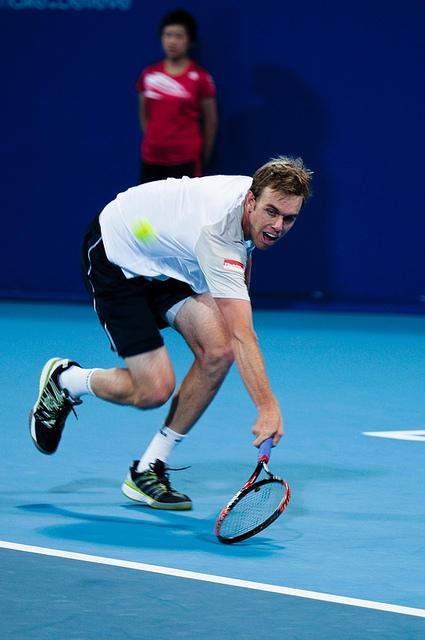What is the job of the person in the red top?
Be succinct. Ball retriever. How many feet does this person have on the ground?
Short answer required. 1. What is the man wearing?
Give a very brief answer. Shorts. Would the person in the red top have experience equality if they had lived 100 years ago?
Be succinct. No. 